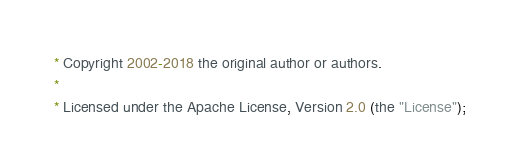Convert code to text. <code><loc_0><loc_0><loc_500><loc_500><_Java_> * Copyright 2002-2018 the original author or authors.
 *
 * Licensed under the Apache License, Version 2.0 (the "License");</code> 